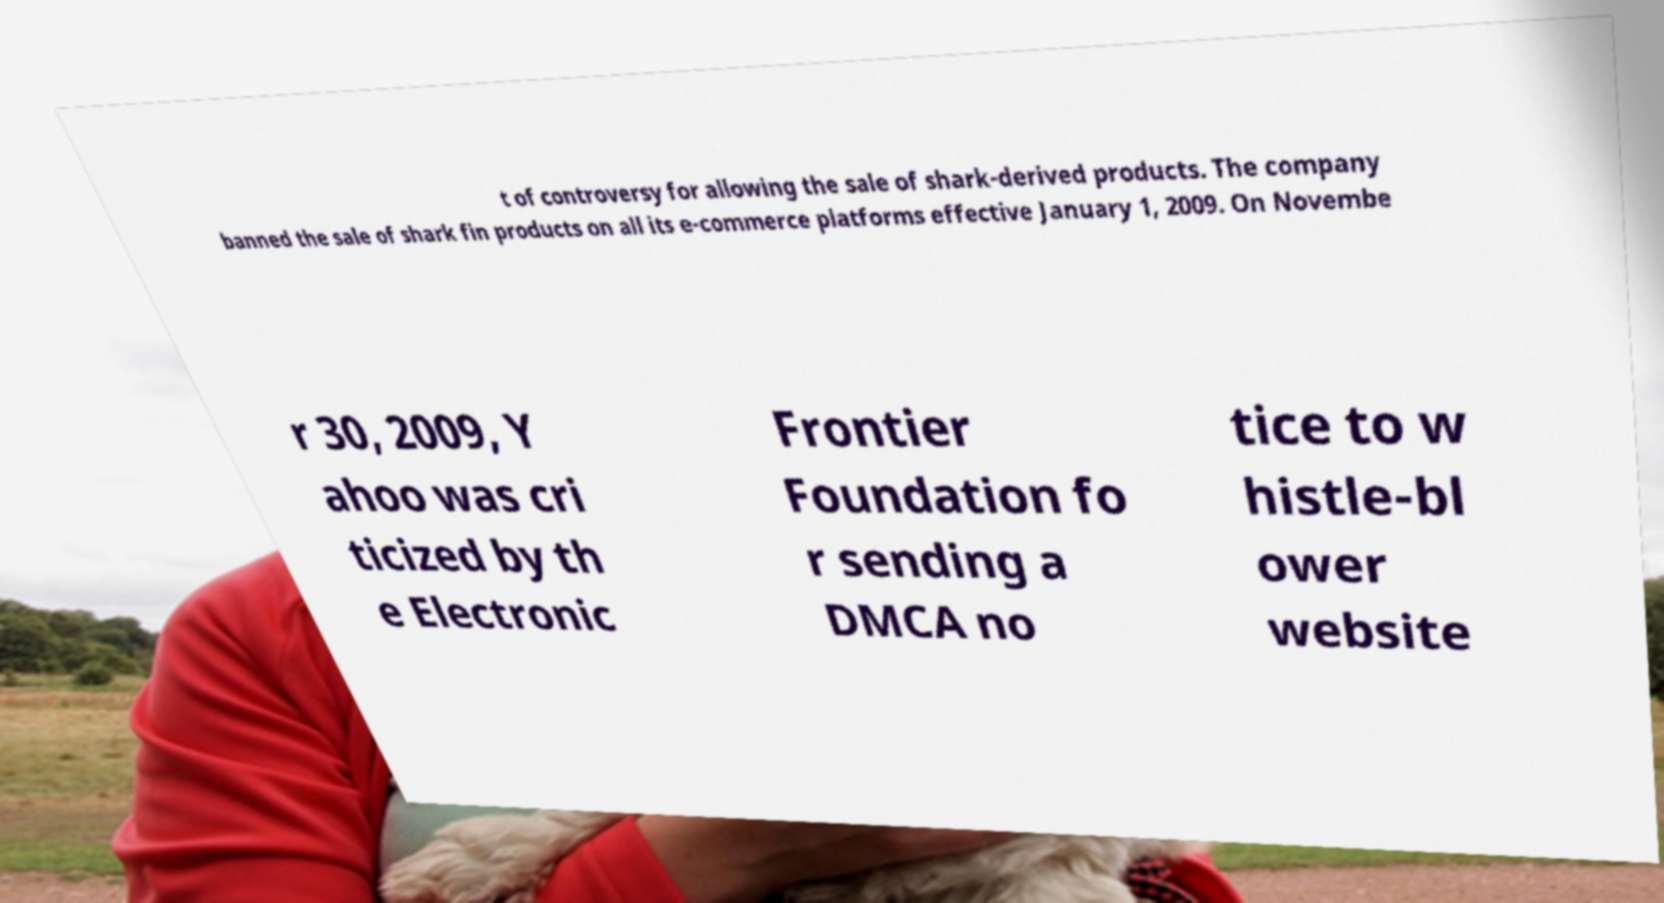Could you assist in decoding the text presented in this image and type it out clearly? t of controversy for allowing the sale of shark-derived products. The company banned the sale of shark fin products on all its e-commerce platforms effective January 1, 2009. On Novembe r 30, 2009, Y ahoo was cri ticized by th e Electronic Frontier Foundation fo r sending a DMCA no tice to w histle-bl ower website 